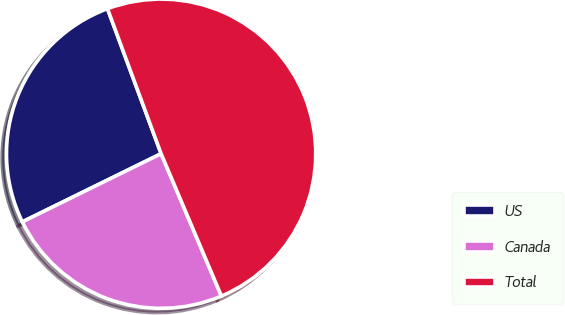<chart> <loc_0><loc_0><loc_500><loc_500><pie_chart><fcel>US<fcel>Canada<fcel>Total<nl><fcel>26.63%<fcel>24.11%<fcel>49.26%<nl></chart> 